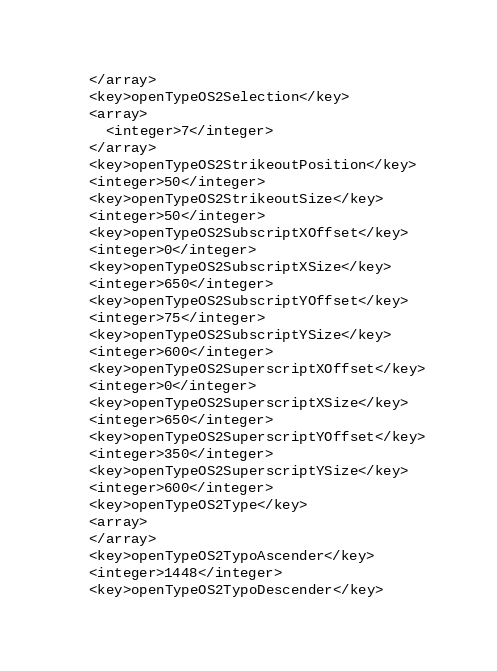<code> <loc_0><loc_0><loc_500><loc_500><_XML_>  </array>
  <key>openTypeOS2Selection</key>
  <array>
    <integer>7</integer>
  </array>
  <key>openTypeOS2StrikeoutPosition</key>
  <integer>50</integer>
  <key>openTypeOS2StrikeoutSize</key>
  <integer>50</integer>
  <key>openTypeOS2SubscriptXOffset</key>
  <integer>0</integer>
  <key>openTypeOS2SubscriptXSize</key>
  <integer>650</integer>
  <key>openTypeOS2SubscriptYOffset</key>
  <integer>75</integer>
  <key>openTypeOS2SubscriptYSize</key>
  <integer>600</integer>
  <key>openTypeOS2SuperscriptXOffset</key>
  <integer>0</integer>
  <key>openTypeOS2SuperscriptXSize</key>
  <integer>650</integer>
  <key>openTypeOS2SuperscriptYOffset</key>
  <integer>350</integer>
  <key>openTypeOS2SuperscriptYSize</key>
  <integer>600</integer>
  <key>openTypeOS2Type</key>
  <array>
  </array>
  <key>openTypeOS2TypoAscender</key>
  <integer>1448</integer>
  <key>openTypeOS2TypoDescender</key></code> 